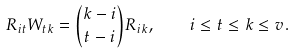Convert formula to latex. <formula><loc_0><loc_0><loc_500><loc_500>R _ { i t } W _ { t k } = { k - i \choose t - i } R _ { i k } , \quad i \leq t \leq k \leq v .</formula> 